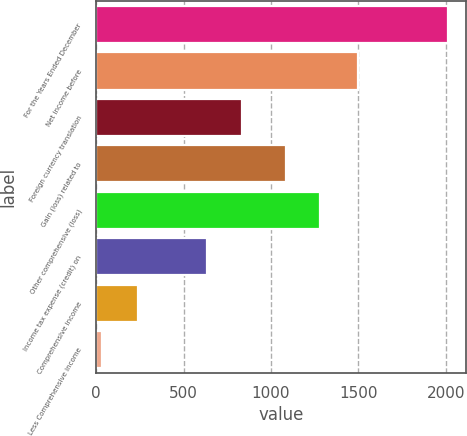Convert chart to OTSL. <chart><loc_0><loc_0><loc_500><loc_500><bar_chart><fcel>For the Years Ended December<fcel>Net income before<fcel>Foreign currency translation<fcel>Gain (loss) related to<fcel>Other comprehensive (loss)<fcel>Income tax expense (credit) on<fcel>Comprehensive income<fcel>Less Comprehensive income<nl><fcel>2014<fcel>1497<fcel>833.6<fcel>1085<fcel>1283.2<fcel>635.4<fcel>239<fcel>32<nl></chart> 